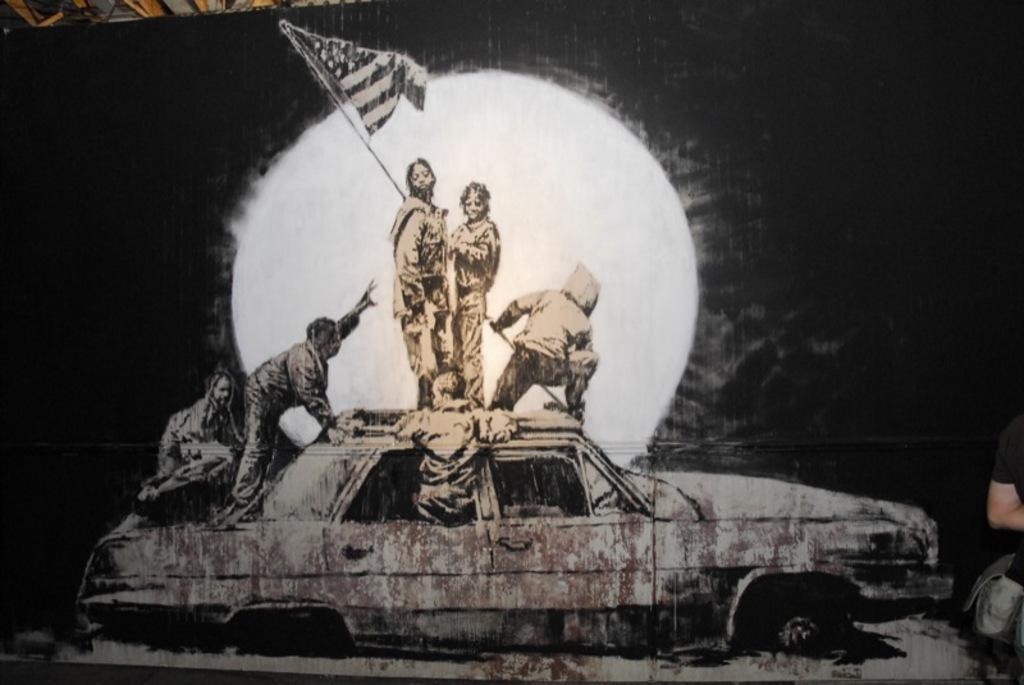In one or two sentences, can you explain what this image depicts? In this image I can see few people on the car and one person is holding the flag. Background is in white and black color. 